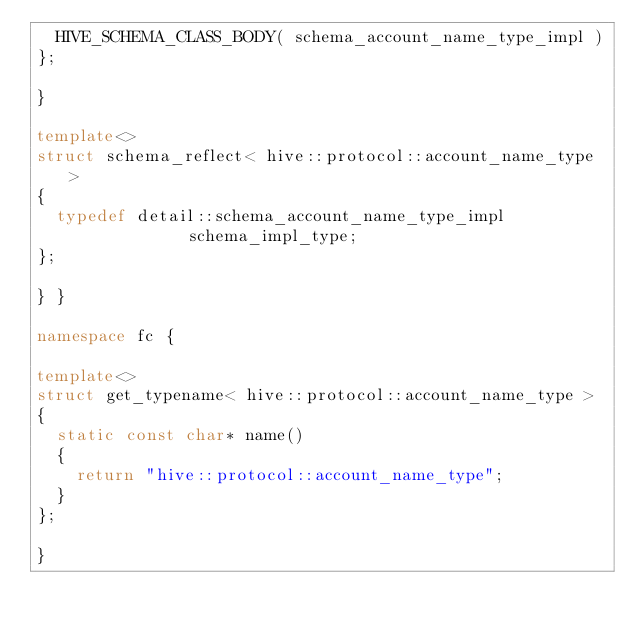<code> <loc_0><loc_0><loc_500><loc_500><_C++_>  HIVE_SCHEMA_CLASS_BODY( schema_account_name_type_impl )
};

}

template<>
struct schema_reflect< hive::protocol::account_name_type >
{
  typedef detail::schema_account_name_type_impl           schema_impl_type;
};

} }

namespace fc {

template<>
struct get_typename< hive::protocol::account_name_type >
{
  static const char* name()
  {
    return "hive::protocol::account_name_type";
  }
};

}
</code> 